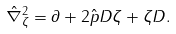<formula> <loc_0><loc_0><loc_500><loc_500>\hat { \nabla } _ { \zeta } ^ { 2 } = \partial + 2 \hat { p } D \zeta + \zeta D .</formula> 